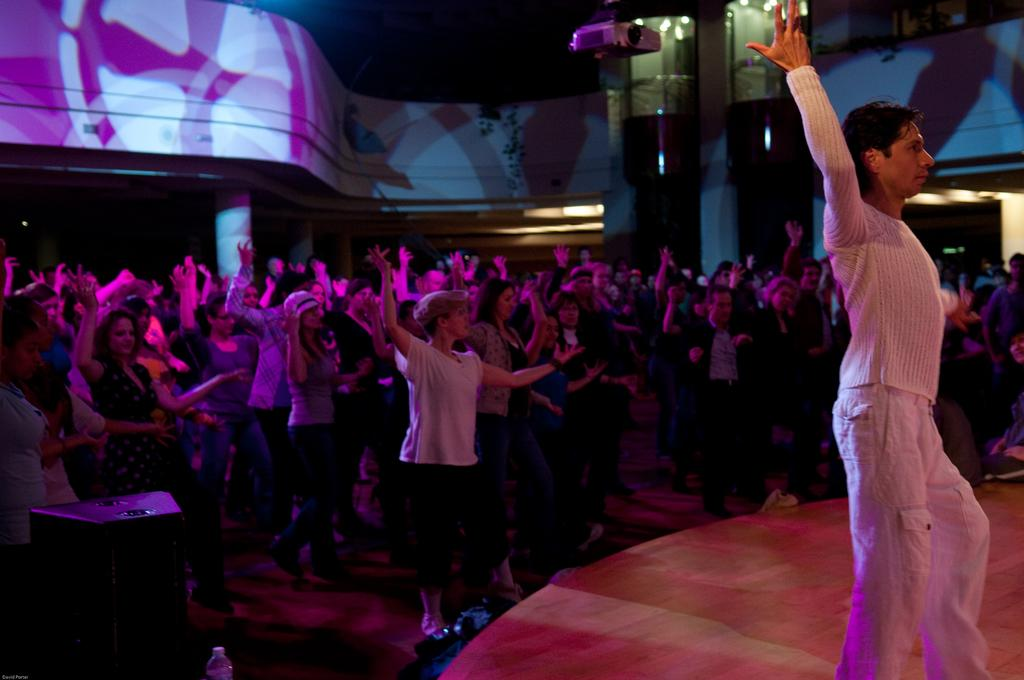What is the main subject of the image? The main subject of the image is a person standing on the stage. What else can be seen in the image besides the person on the stage? There is a group of people standing on the floor, a speaker box, lights, a bottle, a device, a pillar, and a wall visible in the image. What type of plants can be seen growing on the stage in the image? There are no plants visible in the image, let alone growing on the stage. 